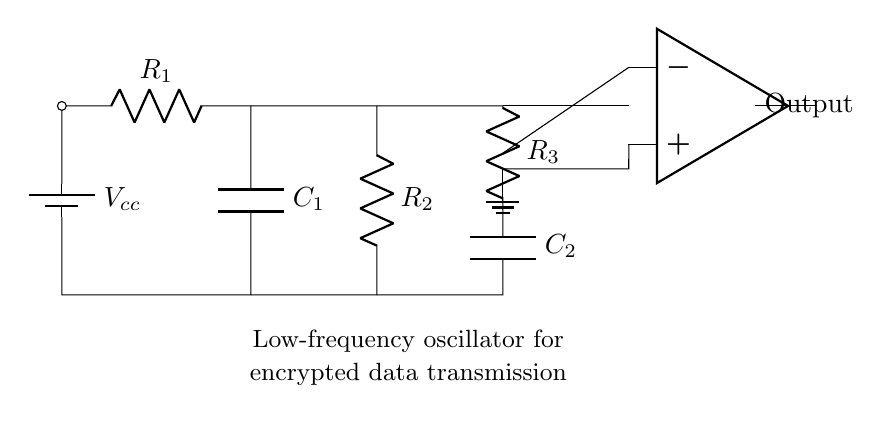What are the components of the circuit? The circuit consists of resistors, capacitors, a battery, and an operational amplifier. Identifying each element in the rendered diagram helps determine the basic building blocks of the circuit.
Answer: Resistors, capacitors, battery, operational amplifier What is the purpose of the circuit? The circuit is designed as a low-frequency oscillator for encrypted data transmission, as noted in the label at the bottom of the diagram. This highlights its specific application in secure communications.
Answer: Low-frequency oscillator for encrypted data transmission How many resistors are in this circuit? The diagram shows three distinct resistors labeled, which can be visually counted. Each resistor has a unique designation, confirming their presence in the circuit.
Answer: Three What is the power supply voltage in the circuit? The circuit is powered by the battery labeled Vcc. The specific voltage, while not numerically indicated, signifies a common voltage source typically used in digital circuits.
Answer: Vcc What is the significance of the operational amplifier in this circuit? The operational amplifier serves as a critical component for signal amplification and feedback in oscillator circuits. Its position and connections indicate it plays a role in generating the oscillatory output needed for data transmission.
Answer: Signal amplification What is the role of the capacitors in this oscillator circuit? The capacitors in an oscillator circuit are used for energy storage and timing control, which influences the oscillation frequency. Notably, both capacitors are integral in shaping the behavior of the circuit's output waveform.
Answer: Timing control and energy storage What type of oscillator is represented by the diagram? This is a low-frequency oscillator, as explicitly stated in the label, distinguished by its operational design to produce lower frequency signals that are often suitable for data transmission in secure communications.
Answer: Low-frequency oscillator 